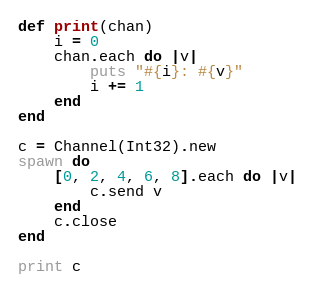<code> <loc_0><loc_0><loc_500><loc_500><_Crystal_>def print(chan)
	i = 0
	chan.each do |v|
		puts "#{i}: #{v}"
		i += 1
	end
end

c = Channel(Int32).new
spawn do
	[0, 2, 4, 6, 8].each do |v|
		c.send v
	end
	c.close
end

print c</code> 